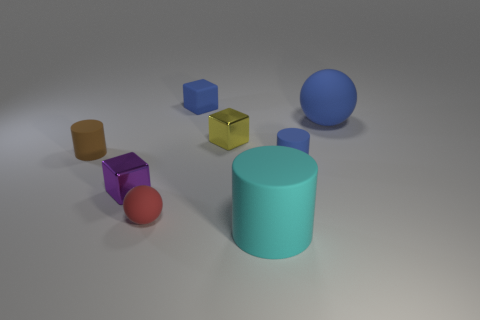There is a purple thing; does it have the same shape as the yellow thing behind the tiny purple metal thing?
Your answer should be very brief. Yes. Is there a thing of the same color as the matte cube?
Make the answer very short. Yes. What is the size of the red ball that is made of the same material as the large blue ball?
Keep it short and to the point. Small. Is the color of the large matte sphere the same as the small rubber block?
Make the answer very short. Yes. Do the big matte thing behind the purple shiny cube and the tiny red rubber object have the same shape?
Your answer should be compact. Yes. What number of other metallic objects are the same size as the yellow object?
Offer a very short reply. 1. What is the shape of the tiny rubber thing that is the same color as the rubber block?
Your response must be concise. Cylinder. Are there any things that are in front of the small matte object that is in front of the purple metallic object?
Offer a very short reply. Yes. How many things are spheres on the left side of the small yellow shiny block or small matte blocks?
Make the answer very short. 2. What number of rubber cylinders are there?
Provide a short and direct response. 3. 